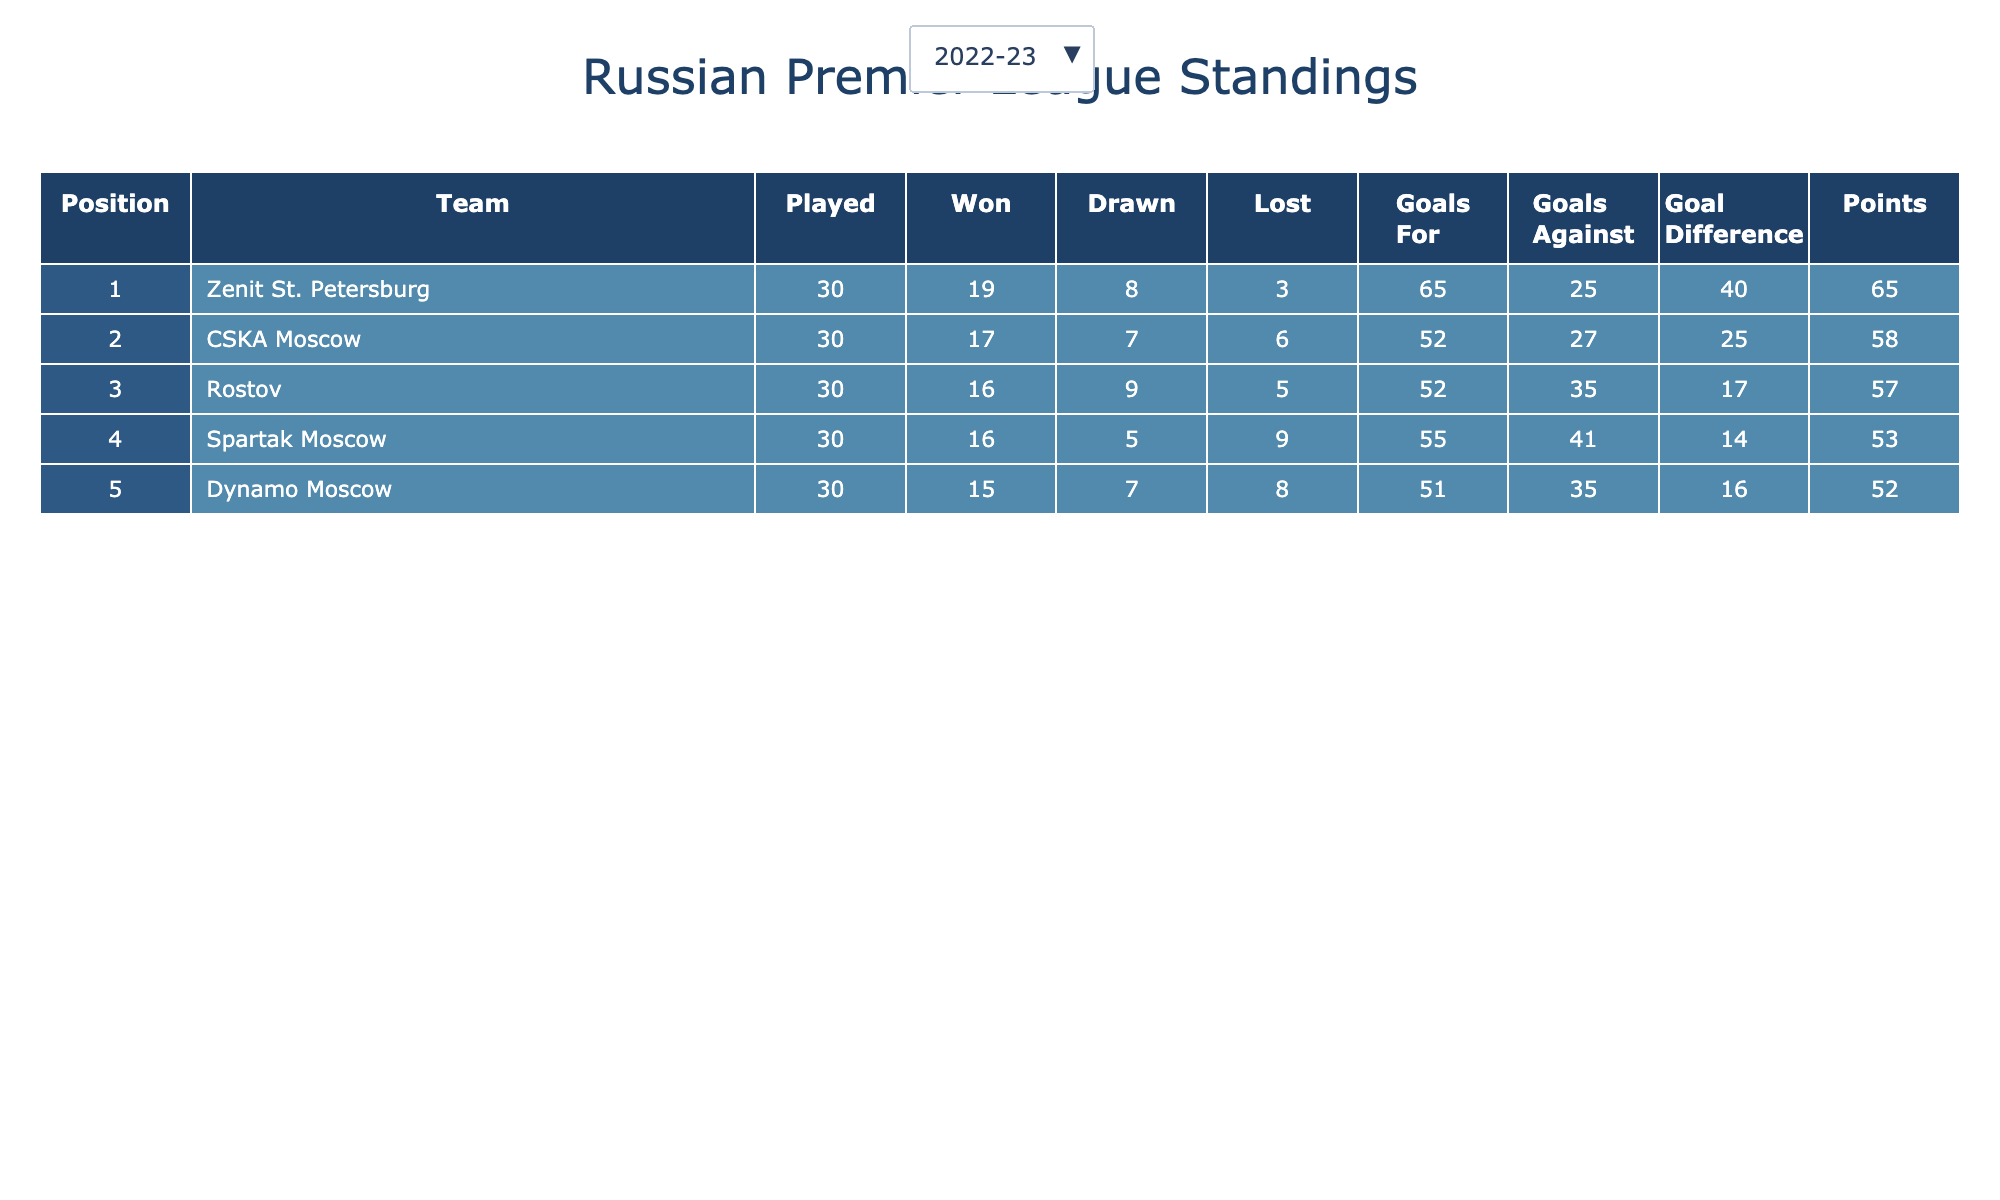What team won the Russian Premier League in the 2022-23 season? In the table, look at the 2022-23 season data and check the team listed in the 1st position, which is Zenit St. Petersburg.
Answer: Zenit St. Petersburg How many goals did CSKA Moscow score in the 2021-22 season? Find CSKA Moscow in the 2021-22 season row, where it shows they scored 48 goals.
Answer: 48 What was the goal difference for Dynamo Moscow in the 2022-23 season? Check the row for Dynamo Moscow in the 2022-23 season to find their goal difference, which is +16.
Answer: +16 Which team had the highest number of Points in 2020-21? In the 2020-21 season, look at all the teams' points and find the highest one from the Zenith St. Petersburg, which has 66 points.
Answer: 66 Which season did Lokomotiv Moscow finish in the second position? Review the table to find Lokomotiv Moscow's positions across seasons; they finished 2nd in the 2020-21 season.
Answer: 2020-21 What is the average number of goals scored by Zenit St. Petersburg in their winning seasons? Zenit won three seasons: 2018-19 (57 goals), 2019-20 (65 goals), 2020-21 (76 goals). The total is 57 + 65 + 76 = 198. The average is 198 / 3 = 66.
Answer: 66 Did Dynamo Moscow finish in the top 3 in the 2020-21 season? Check the table for Dynamo Moscow's position in the 2020-21 season. It is listed in 5th position, so they did not finish in the top 3.
Answer: No What is the total number of wins for Zenit St. Petersburg across all 5 seasons? Add Zenit’s wins from each season: 19 (2022-23) + 19 (2021-22) + 20 (2020-21) + 22 (2019-20) + 20 (2018-19) = 100.
Answer: 100 Which team had the best goal difference in the 2019-20 season and what was it? Look at the 2019-20 season and identify the team with the best goal difference, which is Zenit St. Petersburg with a goal difference of +47.
Answer: Zenit St. Petersburg, +47 How many points difference does Rostov have compared to CSKA Moscow in the 2022-23 season? In the 2022-23 season, Rostov has 57 points and CSKA Moscow has 58 points. The difference is 58 - 57 = 1.
Answer: 1 